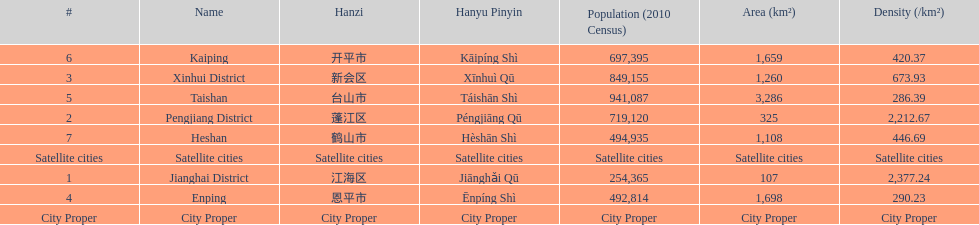Which area is the least dense? Taishan. 